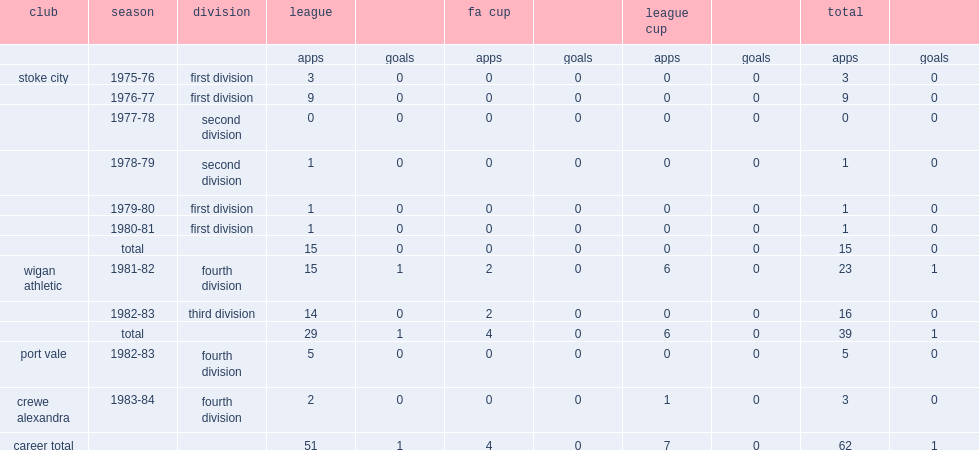Which club did kevin sheldon play for fourth division in 1983-84? Crewe alexandra. Help me parse the entirety of this table. {'header': ['club', 'season', 'division', 'league', '', 'fa cup', '', 'league cup', '', 'total', ''], 'rows': [['', '', '', 'apps', 'goals', 'apps', 'goals', 'apps', 'goals', 'apps', 'goals'], ['stoke city', '1975-76', 'first division', '3', '0', '0', '0', '0', '0', '3', '0'], ['', '1976-77', 'first division', '9', '0', '0', '0', '0', '0', '9', '0'], ['', '1977-78', 'second division', '0', '0', '0', '0', '0', '0', '0', '0'], ['', '1978-79', 'second division', '1', '0', '0', '0', '0', '0', '1', '0'], ['', '1979-80', 'first division', '1', '0', '0', '0', '0', '0', '1', '0'], ['', '1980-81', 'first division', '1', '0', '0', '0', '0', '0', '1', '0'], ['', 'total', '', '15', '0', '0', '0', '0', '0', '15', '0'], ['wigan athletic', '1981-82', 'fourth division', '15', '1', '2', '0', '6', '0', '23', '1'], ['', '1982-83', 'third division', '14', '0', '2', '0', '0', '0', '16', '0'], ['', 'total', '', '29', '1', '4', '0', '6', '0', '39', '1'], ['port vale', '1982-83', 'fourth division', '5', '0', '0', '0', '0', '0', '5', '0'], ['crewe alexandra', '1983-84', 'fourth division', '2', '0', '0', '0', '1', '0', '3', '0'], ['career total', '', '', '51', '1', '4', '0', '7', '0', '62', '1']]} 